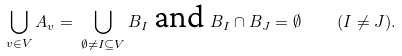Convert formula to latex. <formula><loc_0><loc_0><loc_500><loc_500>\bigcup _ { v \in V } A _ { v } = \, \bigcup _ { \emptyset \neq I \subseteq V } B _ { I } \text {\,and\,} B _ { I } \cap B _ { J } = \emptyset \quad \, ( I \neq J ) .</formula> 